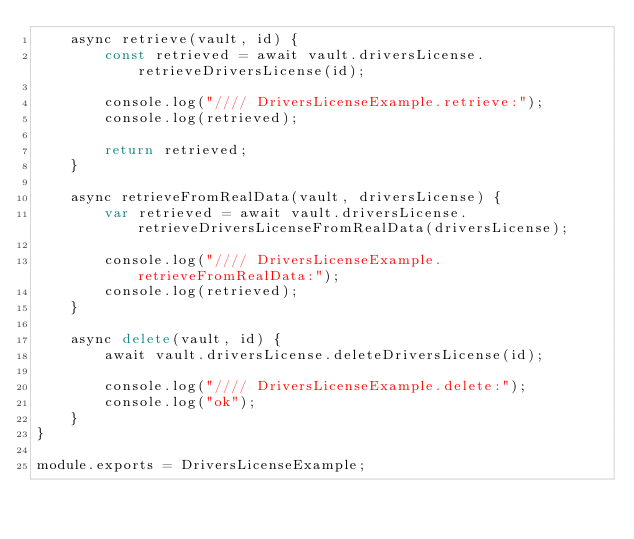Convert code to text. <code><loc_0><loc_0><loc_500><loc_500><_JavaScript_>    async retrieve(vault, id) {
        const retrieved = await vault.driversLicense.retrieveDriversLicense(id);

        console.log("//// DriversLicenseExample.retrieve:");
        console.log(retrieved);

        return retrieved;
    }

    async retrieveFromRealData(vault, driversLicense) {
        var retrieved = await vault.driversLicense.retrieveDriversLicenseFromRealData(driversLicense);

        console.log("//// DriversLicenseExample.retrieveFromRealData:");
        console.log(retrieved);
    }

    async delete(vault, id) {
        await vault.driversLicense.deleteDriversLicense(id);

        console.log("//// DriversLicenseExample.delete:");
        console.log("ok");
    }
}

module.exports = DriversLicenseExample;</code> 